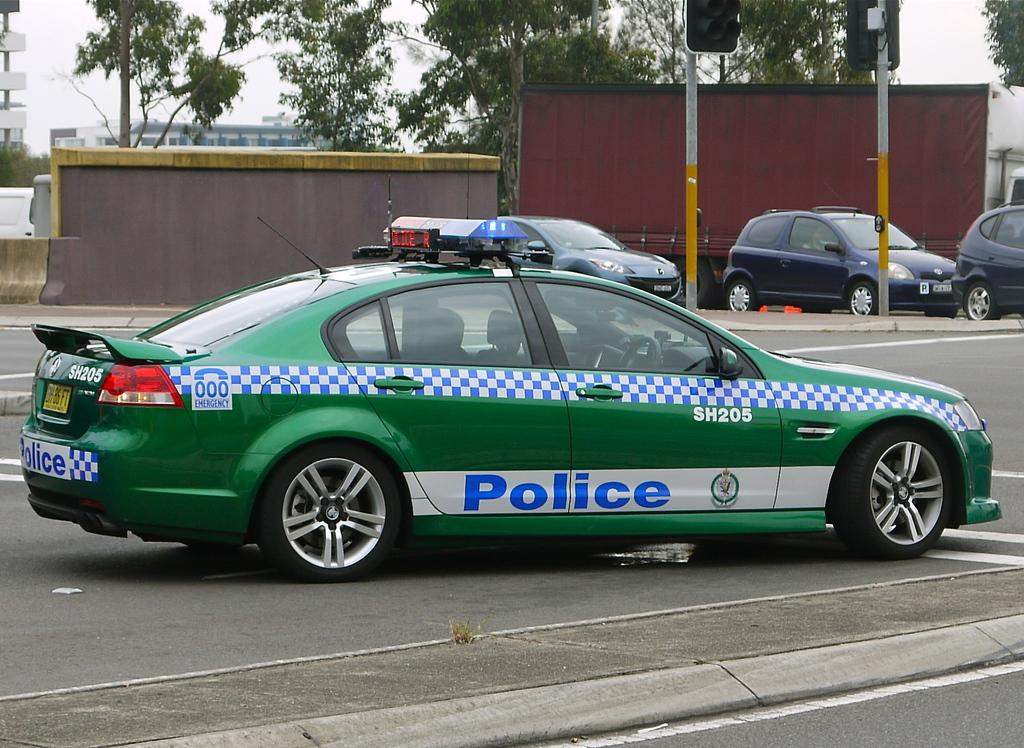<image>
Summarize the visual content of the image. a car that has the word police on it 